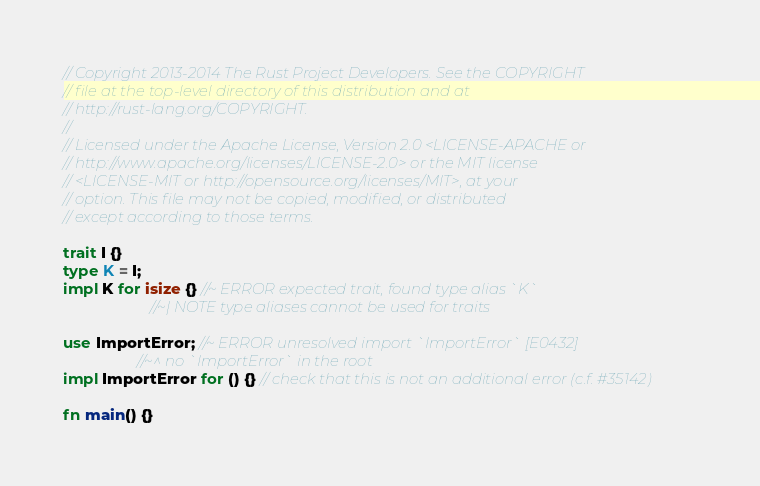Convert code to text. <code><loc_0><loc_0><loc_500><loc_500><_Rust_>// Copyright 2013-2014 The Rust Project Developers. See the COPYRIGHT
// file at the top-level directory of this distribution and at
// http://rust-lang.org/COPYRIGHT.
//
// Licensed under the Apache License, Version 2.0 <LICENSE-APACHE or
// http://www.apache.org/licenses/LICENSE-2.0> or the MIT license
// <LICENSE-MIT or http://opensource.org/licenses/MIT>, at your
// option. This file may not be copied, modified, or distributed
// except according to those terms.

trait I {}
type K = I;
impl K for isize {} //~ ERROR expected trait, found type alias `K`
                    //~| NOTE type aliases cannot be used for traits

use ImportError; //~ ERROR unresolved import `ImportError` [E0432]
                 //~^ no `ImportError` in the root
impl ImportError for () {} // check that this is not an additional error (c.f. #35142)

fn main() {}
</code> 